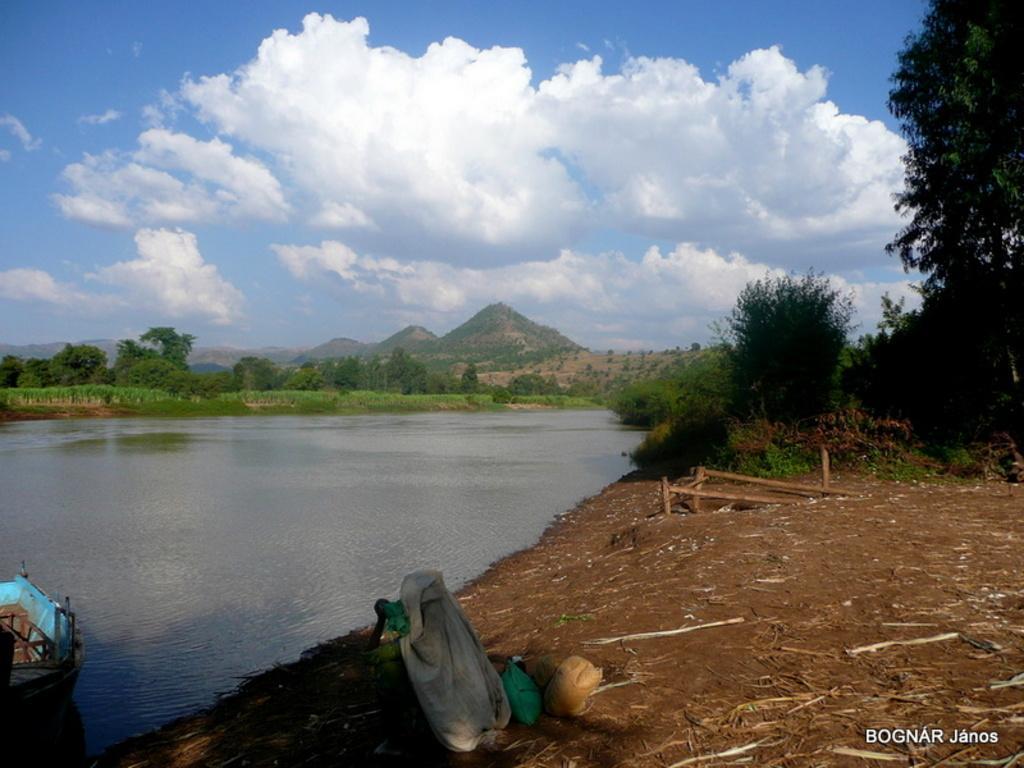How would you summarize this image in a sentence or two? In this image there is water in the middle. At the top there is the sky. In the background there are hills and trees. On the right side there is a ground on which there is a person sitting on it. In the water there is a boat. On the ground there is sand and small wooden sticks. 